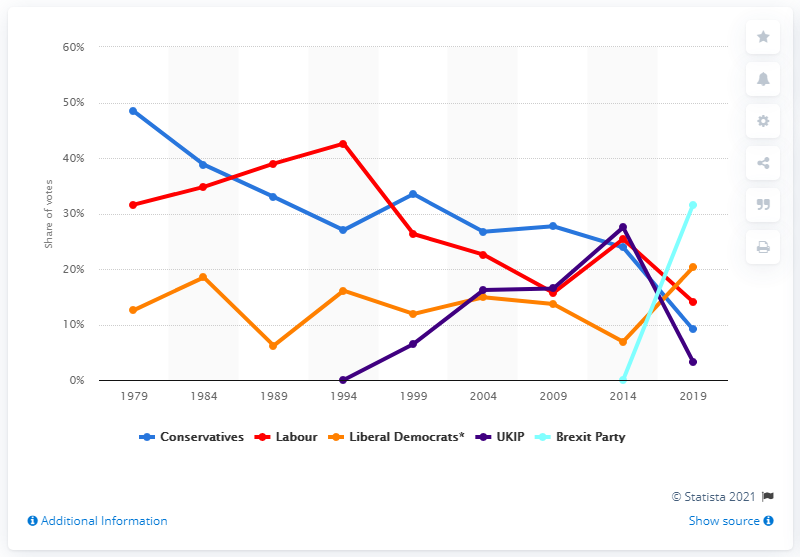List a handful of essential elements in this visual. The newly formed Brexit Party won 31.6% of the vote in their first election. 